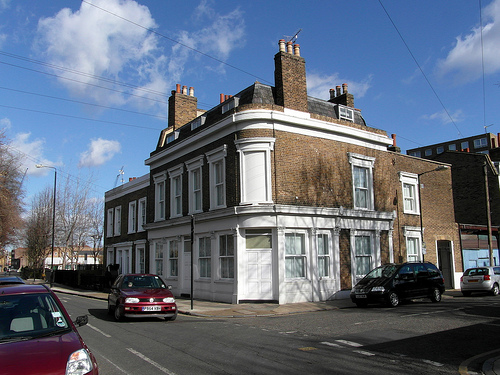<image>
Can you confirm if the building is behind the car? Yes. From this viewpoint, the building is positioned behind the car, with the car partially or fully occluding the building. 